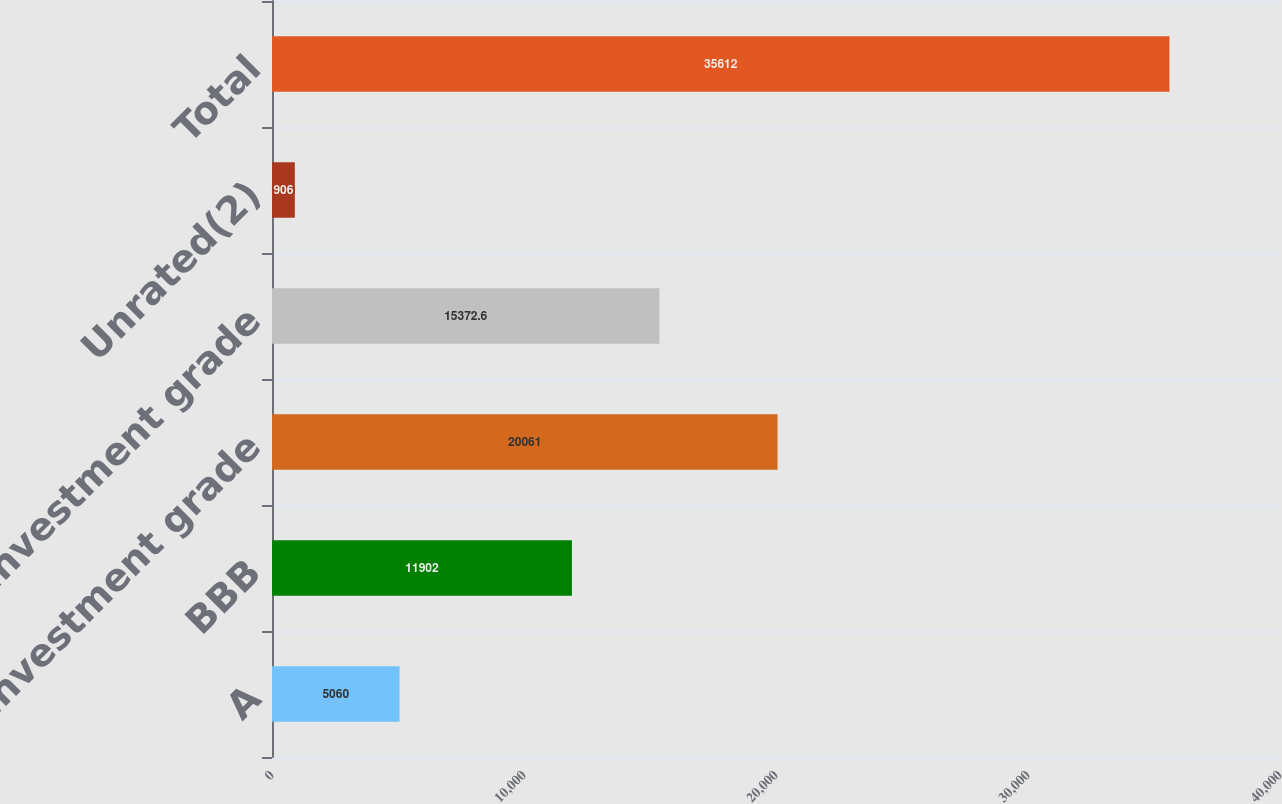<chart> <loc_0><loc_0><loc_500><loc_500><bar_chart><fcel>A<fcel>BBB<fcel>Investment grade<fcel>Non-investment grade<fcel>Unrated(2)<fcel>Total<nl><fcel>5060<fcel>11902<fcel>20061<fcel>15372.6<fcel>906<fcel>35612<nl></chart> 